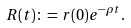Convert formula to latex. <formula><loc_0><loc_0><loc_500><loc_500>R ( t ) \colon = r ( 0 ) e ^ { - \rho t } .</formula> 